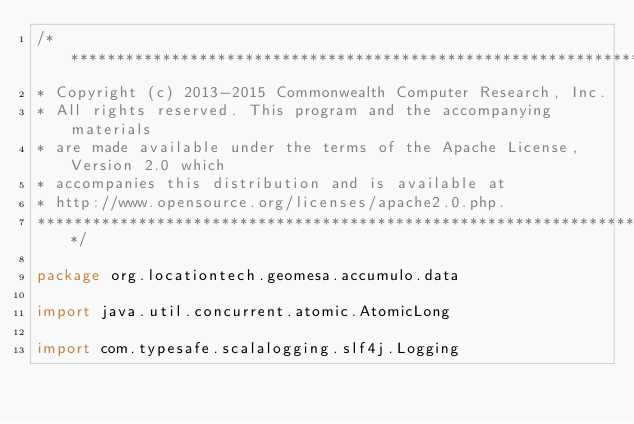<code> <loc_0><loc_0><loc_500><loc_500><_Scala_>/***********************************************************************
* Copyright (c) 2013-2015 Commonwealth Computer Research, Inc.
* All rights reserved. This program and the accompanying materials
* are made available under the terms of the Apache License, Version 2.0 which
* accompanies this distribution and is available at
* http://www.opensource.org/licenses/apache2.0.php.
*************************************************************************/

package org.locationtech.geomesa.accumulo.data

import java.util.concurrent.atomic.AtomicLong

import com.typesafe.scalalogging.slf4j.Logging</code> 